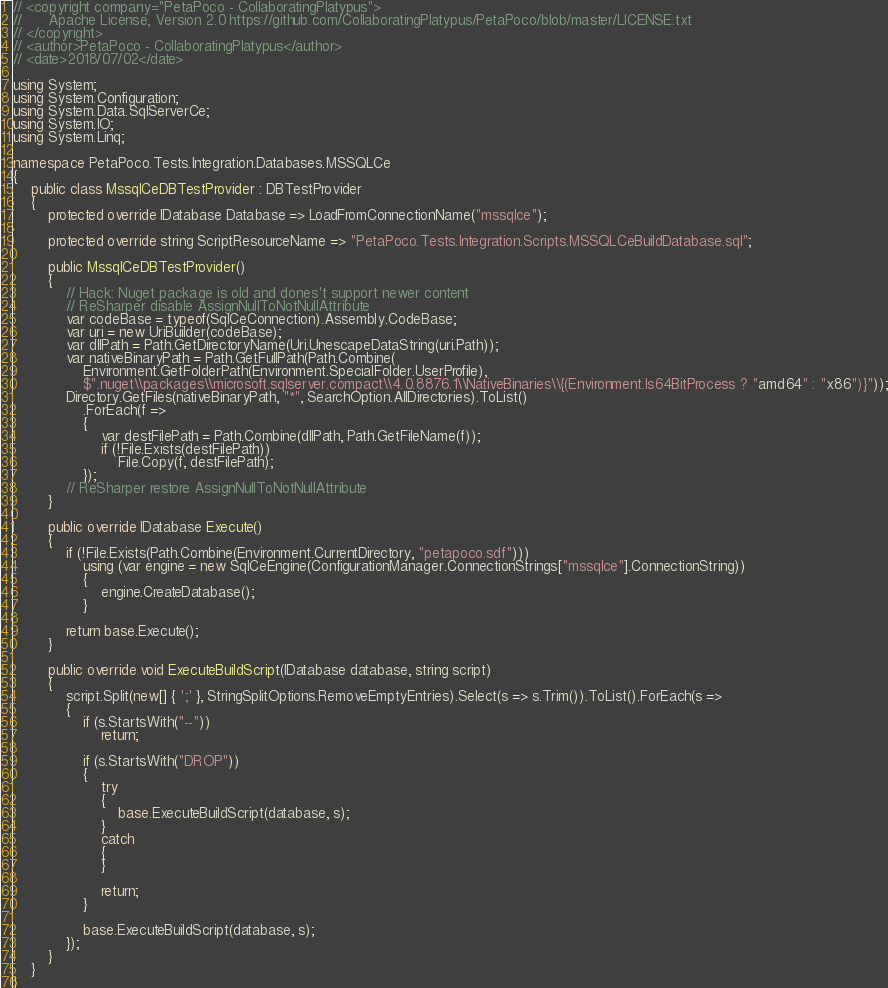<code> <loc_0><loc_0><loc_500><loc_500><_C#_>// <copyright company="PetaPoco - CollaboratingPlatypus">
//      Apache License, Version 2.0 https://github.com/CollaboratingPlatypus/PetaPoco/blob/master/LICENSE.txt
// </copyright>
// <author>PetaPoco - CollaboratingPlatypus</author>
// <date>2018/07/02</date>

using System;
using System.Configuration;
using System.Data.SqlServerCe;
using System.IO;
using System.Linq;

namespace PetaPoco.Tests.Integration.Databases.MSSQLCe
{
    public class MssqlCeDBTestProvider : DBTestProvider
    {
        protected override IDatabase Database => LoadFromConnectionName("mssqlce");

        protected override string ScriptResourceName => "PetaPoco.Tests.Integration.Scripts.MSSQLCeBuildDatabase.sql";

        public MssqlCeDBTestProvider()
        {
            // Hack: Nuget package is old and dones't support newer content
            // ReSharper disable AssignNullToNotNullAttribute
            var codeBase = typeof(SqlCeConnection).Assembly.CodeBase;
            var uri = new UriBuilder(codeBase);
            var dllPath = Path.GetDirectoryName(Uri.UnescapeDataString(uri.Path));
            var nativeBinaryPath = Path.GetFullPath(Path.Combine(
                Environment.GetFolderPath(Environment.SpecialFolder.UserProfile),
                $".nuget\\packages\\microsoft.sqlserver.compact\\4.0.8876.1\\NativeBinaries\\{(Environment.Is64BitProcess ? "amd64" : "x86")}"));
            Directory.GetFiles(nativeBinaryPath, "*", SearchOption.AllDirectories).ToList()
                .ForEach(f =>
                {
                    var destFilePath = Path.Combine(dllPath, Path.GetFileName(f));
                    if (!File.Exists(destFilePath))
                        File.Copy(f, destFilePath);
                });
            // ReSharper restore AssignNullToNotNullAttribute
        }

        public override IDatabase Execute()
        {
            if (!File.Exists(Path.Combine(Environment.CurrentDirectory, "petapoco.sdf")))
                using (var engine = new SqlCeEngine(ConfigurationManager.ConnectionStrings["mssqlce"].ConnectionString))
                {
                    engine.CreateDatabase();
                }

            return base.Execute();
        }

        public override void ExecuteBuildScript(IDatabase database, string script)
        {
            script.Split(new[] { ';' }, StringSplitOptions.RemoveEmptyEntries).Select(s => s.Trim()).ToList().ForEach(s =>
            {
                if (s.StartsWith("--"))
                    return;

                if (s.StartsWith("DROP"))
                {
                    try
                    {
                        base.ExecuteBuildScript(database, s);
                    }
                    catch
                    {
                    }

                    return;
                }

                base.ExecuteBuildScript(database, s);
            });
        }
    }
}</code> 